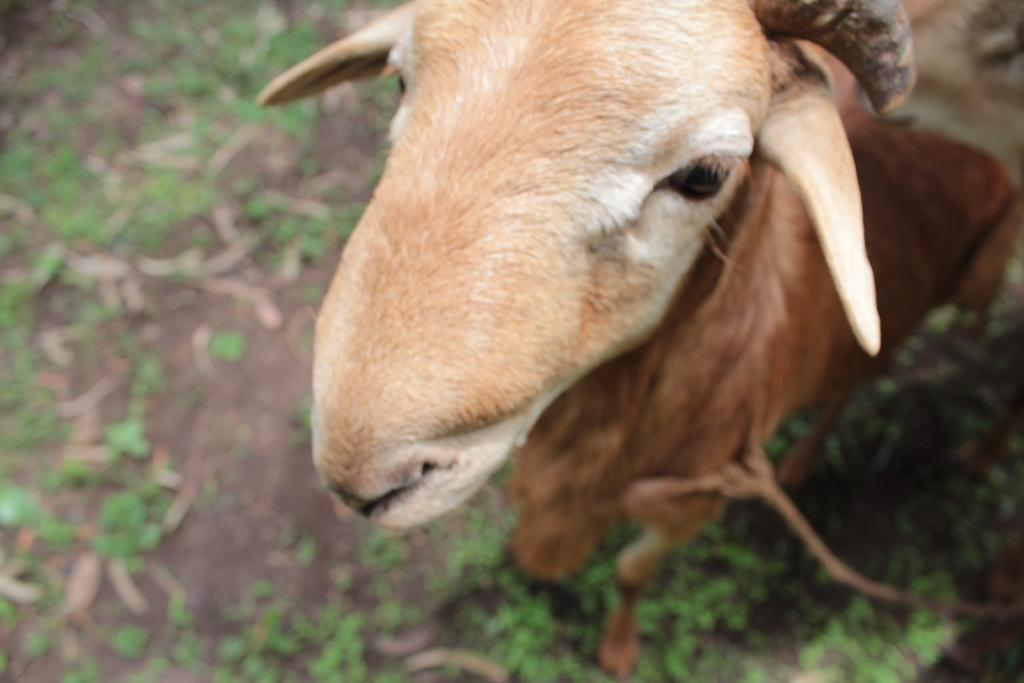What animal is present in the image? There is a goat in the image. On which side of the image is the goat located? The goat is on the right side of the image. What type of surface is visible in the image? There is a floor in the image. On which side of the image is the floor located? The floor is on the left side of the image. What is the goat's belief about the cave in the image? There is no cave present in the image, so the goat's belief about a cave cannot be determined. 